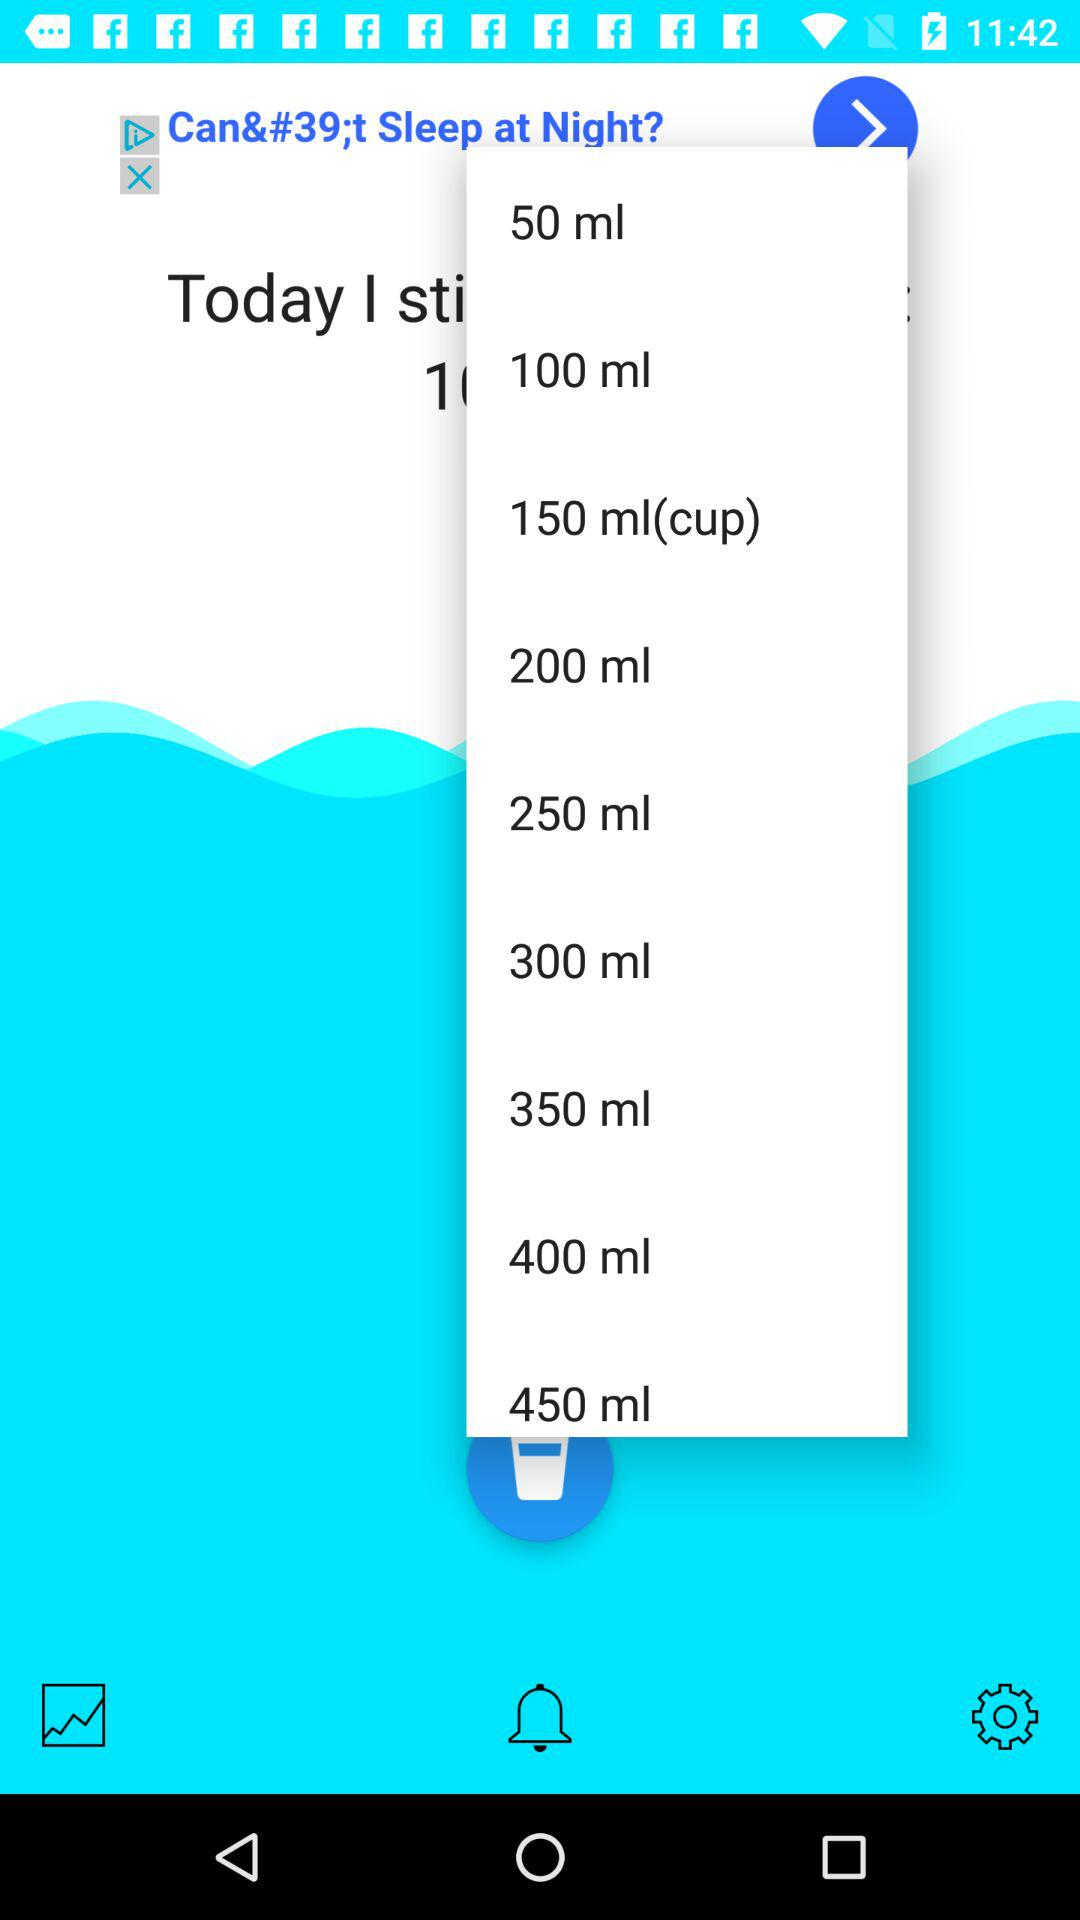How many ml options are there?
Answer the question using a single word or phrase. 9 